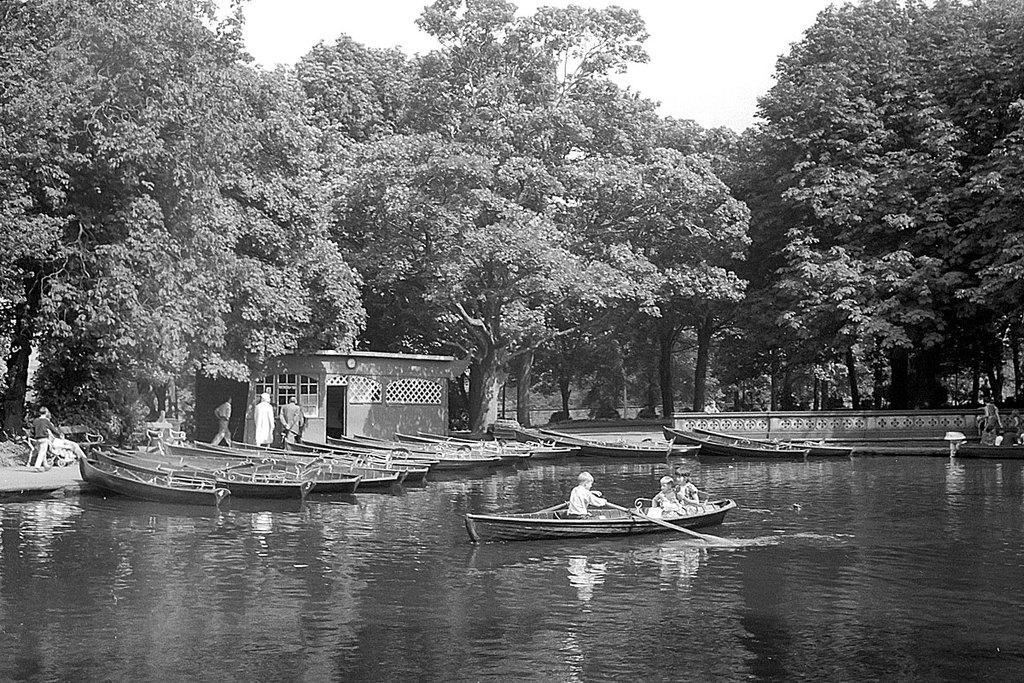Please provide a concise description of this image. In this picture I can see a few trees and few boats in the water and I can see couple of them walking and few are standing and I am see a small house and and few are sitting in the boat and I can see a boy holding paddles and I can see sky. 